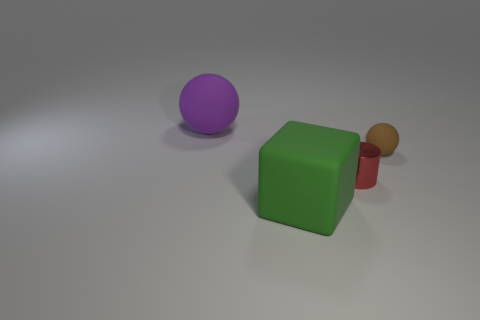Is there anything else that is the same material as the cylinder?
Make the answer very short. No. How many red shiny things are to the left of the large matte thing on the right side of the purple rubber thing?
Ensure brevity in your answer.  0. How many other things are the same size as the purple rubber object?
Give a very brief answer. 1. How many things are either tiny gray shiny cylinders or objects that are on the right side of the tiny red shiny cylinder?
Keep it short and to the point. 1. Is the number of big objects less than the number of tiny matte objects?
Your answer should be compact. No. What color is the large rubber object that is on the right side of the large matte object behind the large block?
Give a very brief answer. Green. What number of rubber objects are either tiny cylinders or big cyan cylinders?
Provide a succinct answer. 0. Is the material of the thing that is to the right of the metallic object the same as the tiny thing that is to the left of the small brown rubber sphere?
Ensure brevity in your answer.  No. Is there a large metal sphere?
Give a very brief answer. No. There is a large thing that is in front of the small metal thing; does it have the same shape as the rubber object that is behind the brown matte sphere?
Provide a succinct answer. No. 